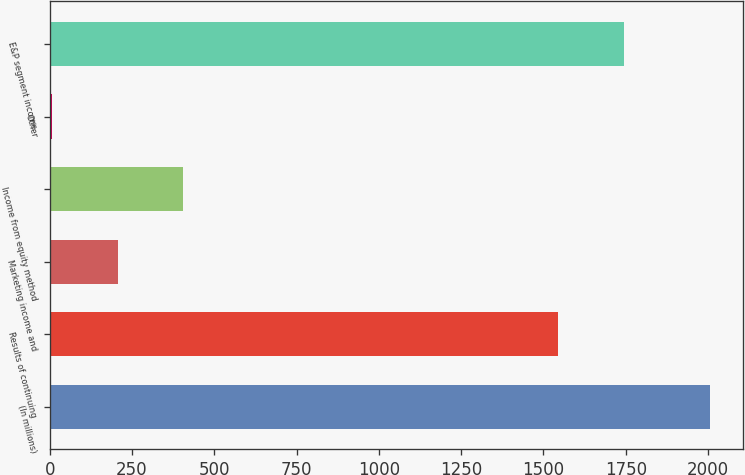<chart> <loc_0><loc_0><loc_500><loc_500><bar_chart><fcel>(In millions)<fcel>Results of continuing<fcel>Marketing income and<fcel>Income from equity method<fcel>Other<fcel>E&P segment income<nl><fcel>2007<fcel>1545<fcel>206.1<fcel>406.2<fcel>6<fcel>1745.1<nl></chart> 